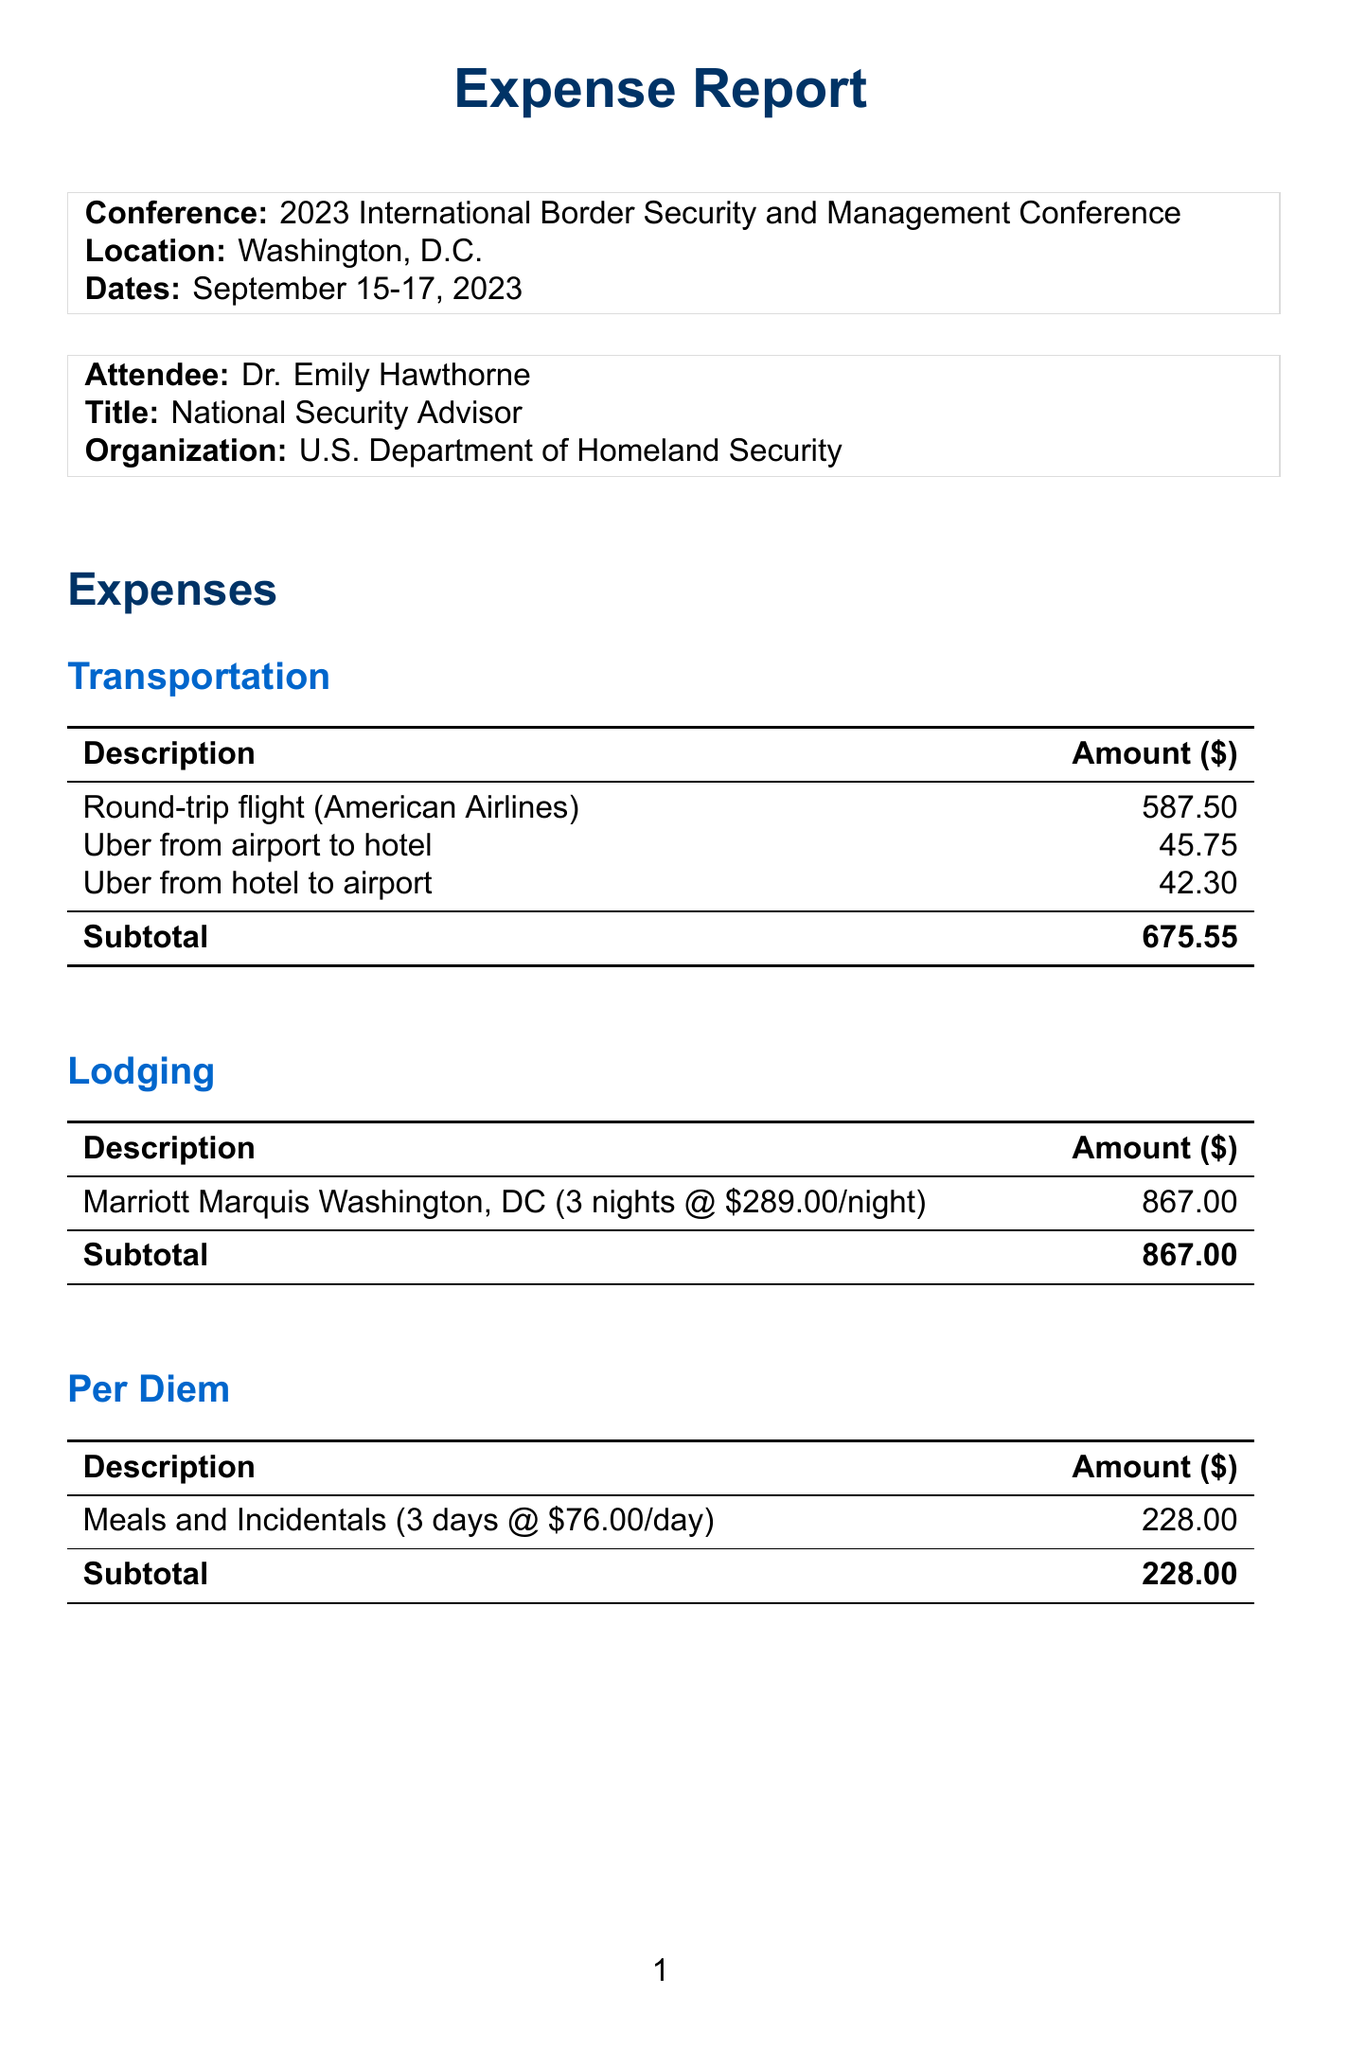what is the conference name? The conference name is listed at the beginning of the document.
Answer: 2023 International Border Security and Management Conference who is the attendee? The attendee's name is specified in the attendee section of the document.
Answer: Dr. Emily Hawthorne what is the total amount of lodging expenses? The total lodging expenses can be found in the lodging section of the document.
Answer: 867.00 how many nights was the lodging for? The number of nights for lodging is mentioned in the lodging category.
Answer: 3 what is the rate per day for per diem? The rate per day for per diem is detailed in the per diem section of the document.
Answer: 76.00 what method was used for payment? The payment method is mentioned towards the end of the report.
Answer: Government-issued credit card what was the subtotal for transportation expenses? The subtotal for transportation is indicated at the end of the transportation category.
Answer: 675.55 what is the total amount of expenses reported? The total expenses are calculated and presented at the conclusion of the document.
Answer: 2594.30 who approved the expense report? The name of the person who approved the report is listed towards the end of the document.
Answer: James R. Thompson 